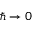<formula> <loc_0><loc_0><loc_500><loc_500>\hslash \to 0</formula> 